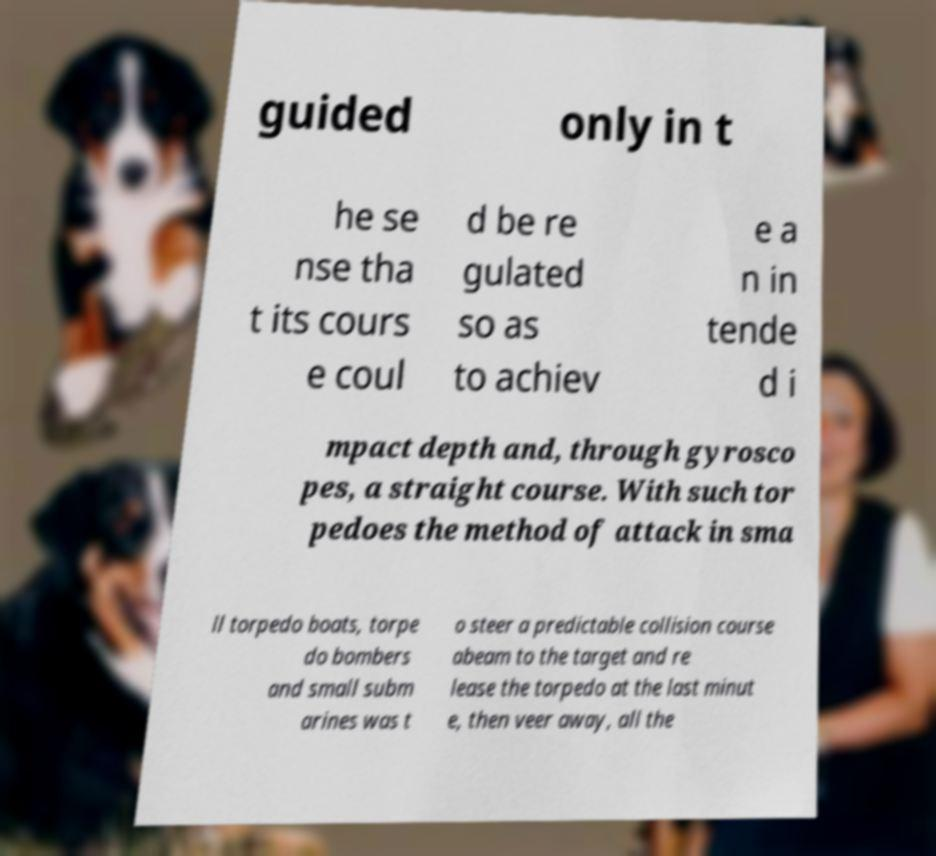What messages or text are displayed in this image? I need them in a readable, typed format. guided only in t he se nse tha t its cours e coul d be re gulated so as to achiev e a n in tende d i mpact depth and, through gyrosco pes, a straight course. With such tor pedoes the method of attack in sma ll torpedo boats, torpe do bombers and small subm arines was t o steer a predictable collision course abeam to the target and re lease the torpedo at the last minut e, then veer away, all the 